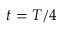<formula> <loc_0><loc_0><loc_500><loc_500>t = T / 4</formula> 